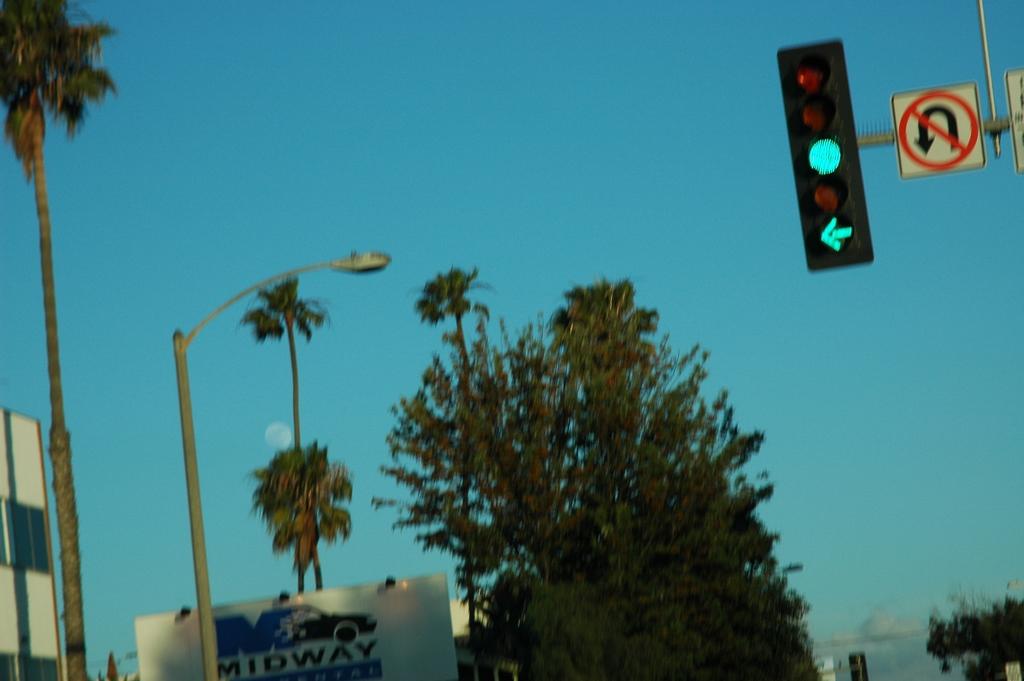What company is the sign in the lower left advertising?
Give a very brief answer. Midway. 